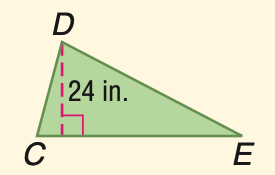Answer the mathemtical geometry problem and directly provide the correct option letter.
Question: Triangle C D E has an area of 336 square inches. Find C E.
Choices: A: 24 B: 26 C: 28 D: 32 C 